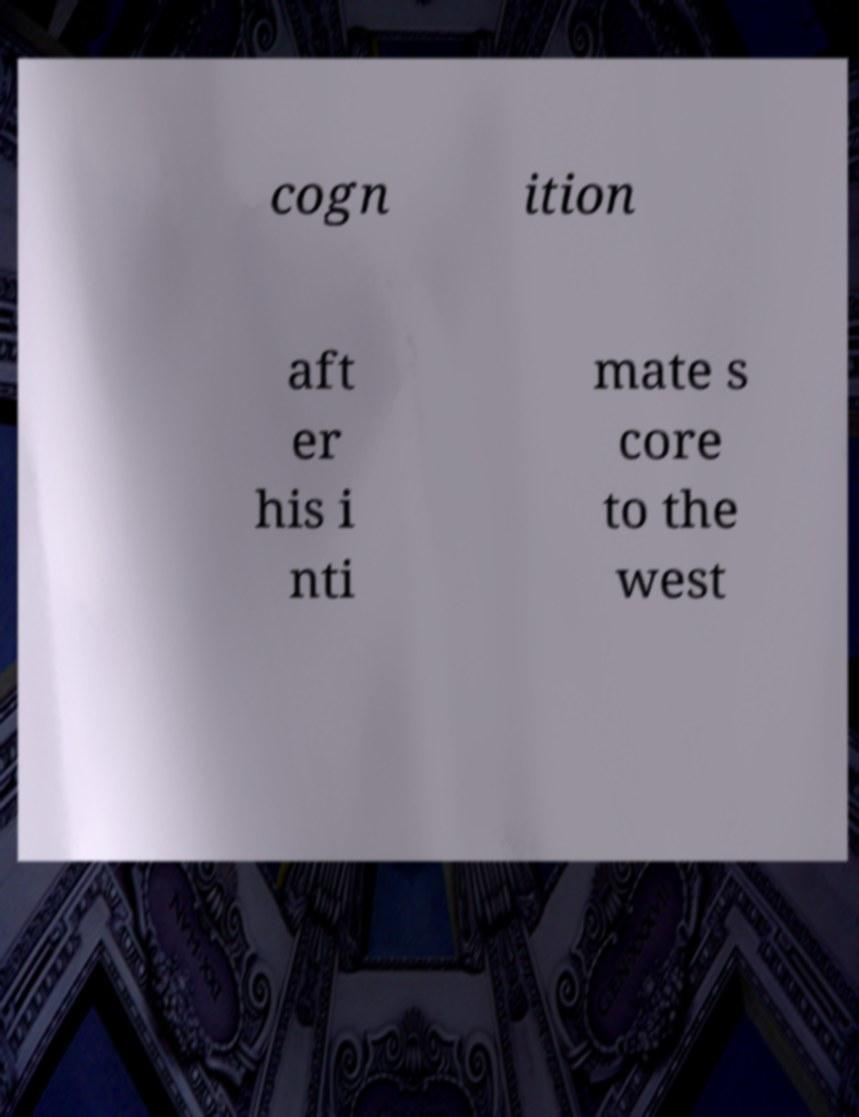There's text embedded in this image that I need extracted. Can you transcribe it verbatim? cogn ition aft er his i nti mate s core to the west 